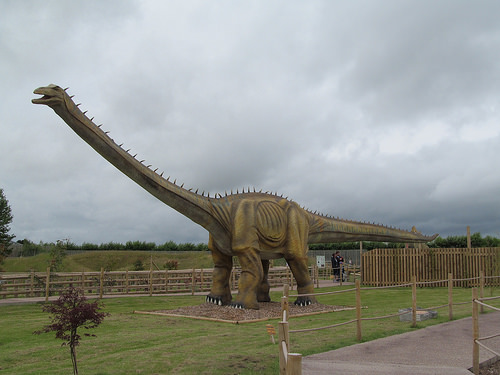<image>
Is there a head in front of the tail? Yes. The head is positioned in front of the tail, appearing closer to the camera viewpoint. 